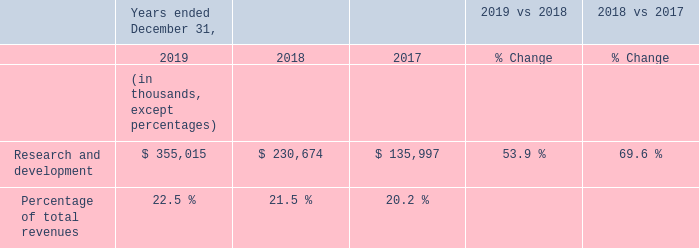Research and Development
Research and development expenses increased $124.3 million, or 53.9%, for the year ended December 31, 2019 compared to the same period in 2018, due to an increase of $114.4 million in employee-related costs ($45.1 million of which related to stock-based compensation and related payroll taxes), a $7.4 million increase in computer hardware and software costs, and a $2.5 million increase in professional services fees, all as a result of growth in our research and development employee base and expanded development programs.
Research and development expenses increased $94.7 million, or 69.6%, for the year ended December 31, 2018 compared to the same period in 2017, due to an increase of $89.6 million in employee-related costs, an increase of $3.1 million in computer hardware and software costs, and a $2.0 million increase in professional services fees, all as a result of growth in our research and development employee base and expanded development programs.
How much is the research and development expenses for the year ended 2019?
Answer scale should be: thousand. $ 355,015. How much is the research and development expenses for the year ended 2018?
Answer scale should be: thousand. $ 230,674. How much is the research and development expenses for the year ended 2017?
Answer scale should be: thousand. $ 135,997. What is the average research and development expenses for 2018 and 2019?
Answer scale should be: thousand. (355,015+230,674)/2
Answer: 292844.5. What is the average research and development expenses for 2017 and 2018?
Answer scale should be: thousand. (230,674+135,997)/2
Answer: 183335.5. Between year ended 2018 and 2019, which year had higher research and development expenses? 355,015> 230,674
Answer: 2019. 